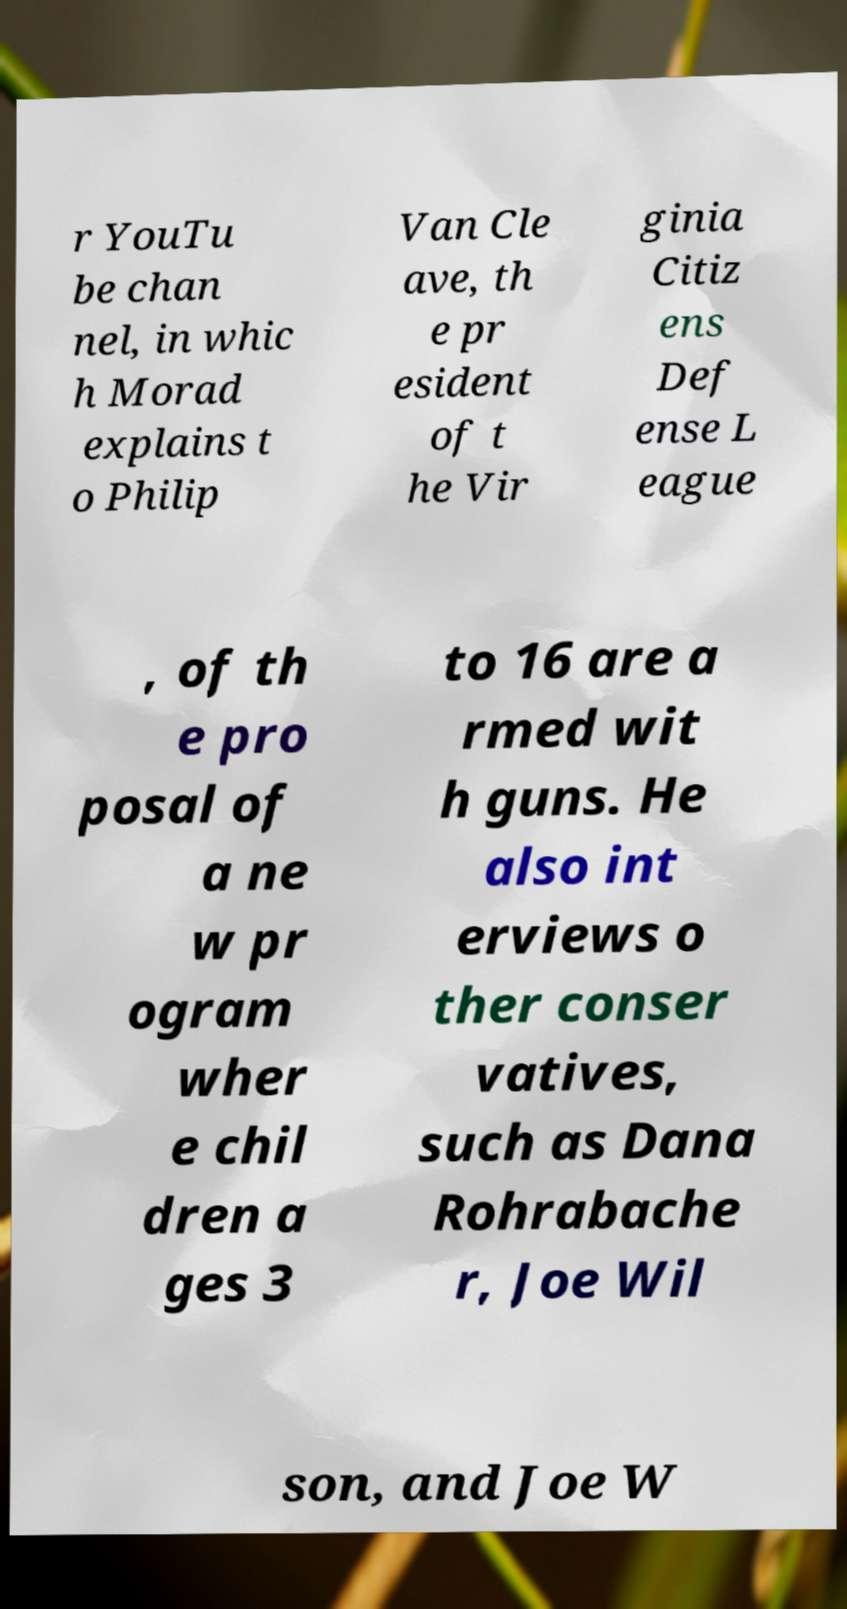Can you accurately transcribe the text from the provided image for me? r YouTu be chan nel, in whic h Morad explains t o Philip Van Cle ave, th e pr esident of t he Vir ginia Citiz ens Def ense L eague , of th e pro posal of a ne w pr ogram wher e chil dren a ges 3 to 16 are a rmed wit h guns. He also int erviews o ther conser vatives, such as Dana Rohrabache r, Joe Wil son, and Joe W 